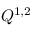Convert formula to latex. <formula><loc_0><loc_0><loc_500><loc_500>Q ^ { 1 , 2 }</formula> 